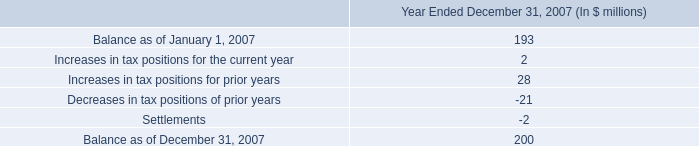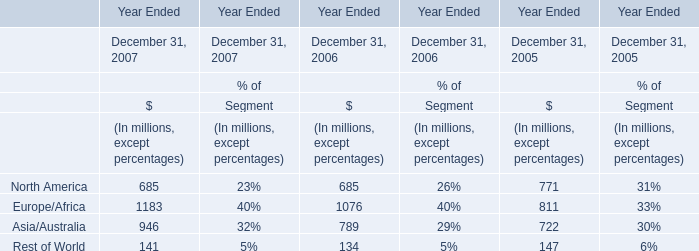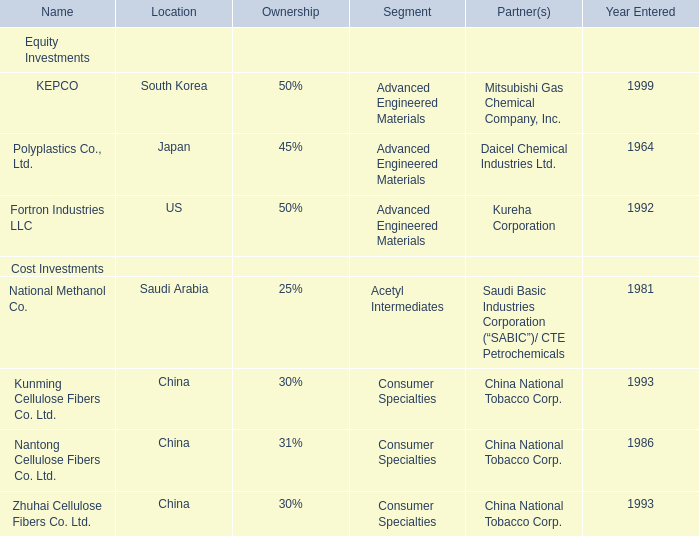in 2007 what was the percentage change in the account balance of unrecognized tax benefits based on the reconciliation at december 31 . 
Computations: ((2000 - 193) / 193)
Answer: 9.36269. 